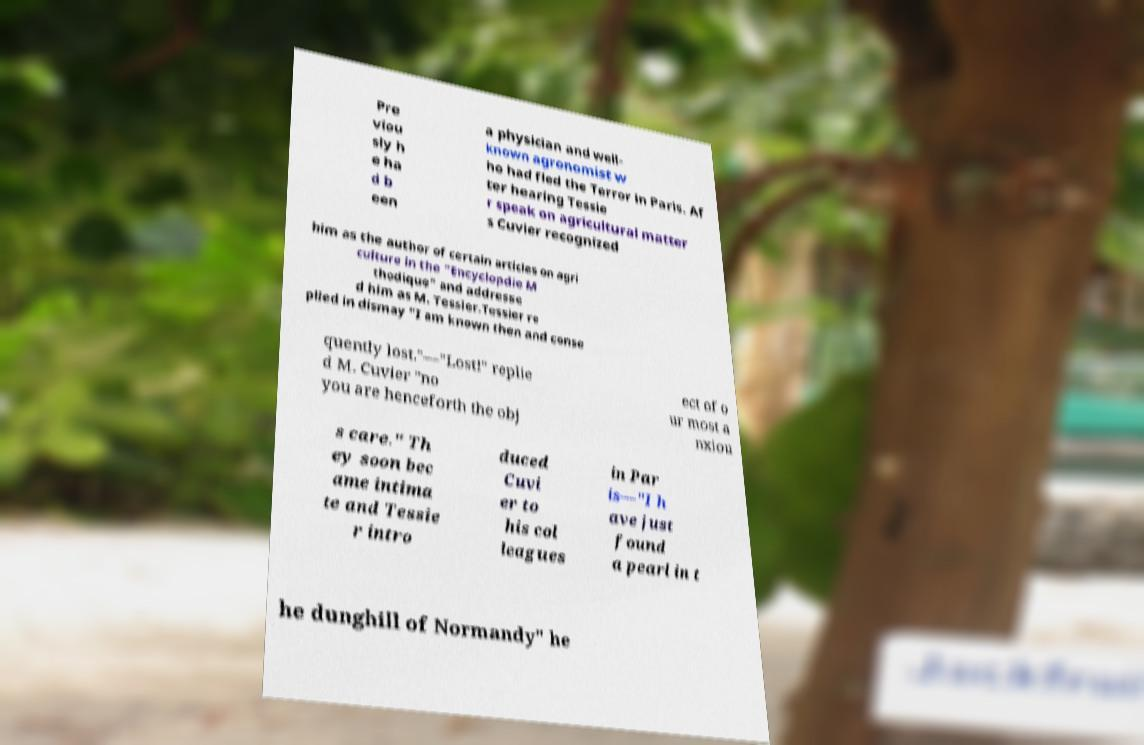Can you read and provide the text displayed in the image?This photo seems to have some interesting text. Can you extract and type it out for me? Pre viou sly h e ha d b een a physician and well- known agronomist w ho had fled the Terror in Paris. Af ter hearing Tessie r speak on agricultural matter s Cuvier recognized him as the author of certain articles on agri culture in the "Encyclopdie M thodique" and addresse d him as M. Tessier.Tessier re plied in dismay "I am known then and conse quently lost."—"Lost!" replie d M. Cuvier "no you are henceforth the obj ect of o ur most a nxiou s care." Th ey soon bec ame intima te and Tessie r intro duced Cuvi er to his col leagues in Par is—"I h ave just found a pearl in t he dunghill of Normandy" he 